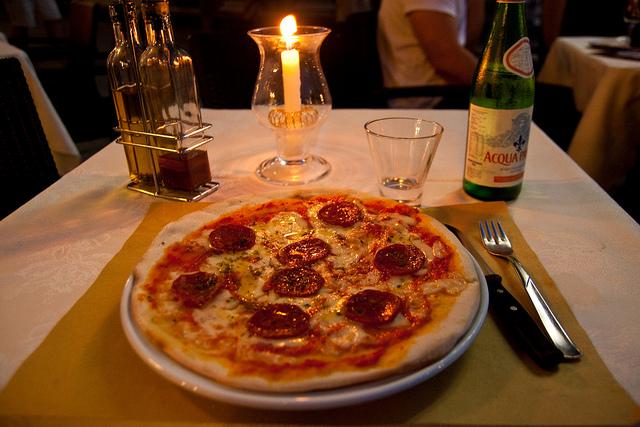Is there pepperoni on the pizza?
Be succinct. Yes. Is the glass empty?
Be succinct. Yes. Why is a candle lit?
Concise answer only. For light. 